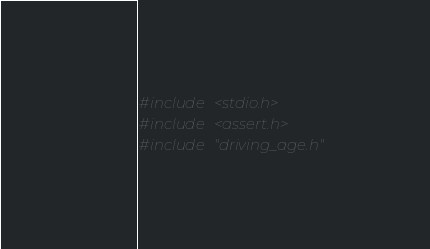<code> <loc_0><loc_0><loc_500><loc_500><_C_>#include <stdio.h>
#include <assert.h>
#include "driving_age.h"
</code> 